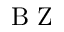<formula> <loc_0><loc_0><loc_500><loc_500>B Z</formula> 